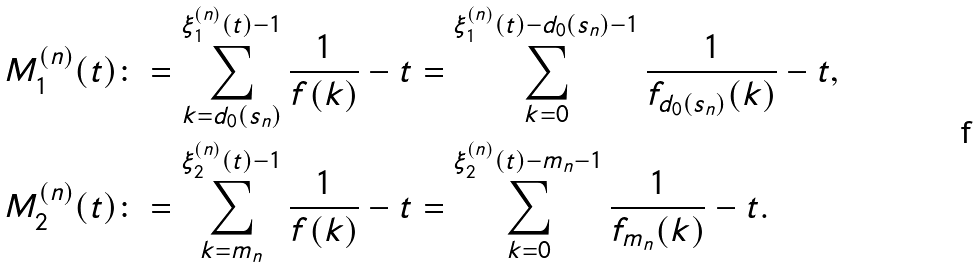<formula> <loc_0><loc_0><loc_500><loc_500>M ^ { ( n ) } _ { 1 } ( t ) & \colon = \sum _ { k = d _ { 0 } ( s _ { n } ) } ^ { \xi _ { 1 } ^ { ( n ) } ( t ) - 1 } \frac { 1 } { f ( k ) } - t = \sum _ { k = 0 } ^ { \xi _ { 1 } ^ { ( n ) } ( t ) - d _ { 0 } ( s _ { n } ) - 1 } \frac { 1 } { f _ { d _ { 0 } ( s _ { n } ) } ( k ) } - t , \\ M ^ { ( n ) } _ { 2 } ( t ) & \colon = \sum _ { k = m _ { n } } ^ { \xi _ { 2 } ^ { ( n ) } ( t ) - 1 } \frac { 1 } { f ( k ) } - t = \sum _ { k = 0 } ^ { \xi _ { 2 } ^ { ( n ) } ( t ) - m _ { n } - 1 } \frac { 1 } { f _ { m _ { n } } ( k ) } - t .</formula> 